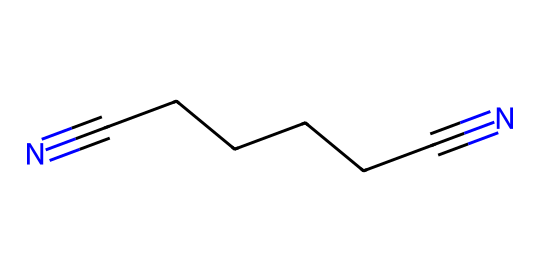What is the name of this chemical? The SMILES representation shows two terminal cyano groups (N#C) and a linear carbon chain (C-C-C-C-C) in between. This structure corresponds to the chemical name "adiponitrile."
Answer: adiponitrile How many carbon atoms are present in adiponitrile? By analyzing the carbon skeleton in the SMILES representation, we see there are 6 carbon atoms (C-C-C-C-C-C) indicated by the chain of 'C' letters.
Answer: 6 What is the functional group in adiponitrile? The presence of the cyano groups (N#C) at both ends of the carbon chain indicates that the functional group is a nitrile, which is characterized by a carbon triple-bonded to a nitrogen.
Answer: nitrile What is the total number of nitrogen atoms in adiponitrile? By counting the nitrogen atoms from the cyano groups in the SMILES representation, we see two nitrogen atoms at the ends of the structure (N#...#N).
Answer: 2 What is the degree of unsaturation in adiponitrile? The presence of the two triple bonds at both ends contributes to the count of degrees of unsaturation; here, the presence of two cyano groups indicates 4 degrees of unsaturation (since each triple bond contributes 2).
Answer: 4 How many total atoms are in this compound? To find the total number of atoms, add the carbon and nitrogen atoms: 6 carbon + 2 nitrogen = 8 total atoms.
Answer: 8 